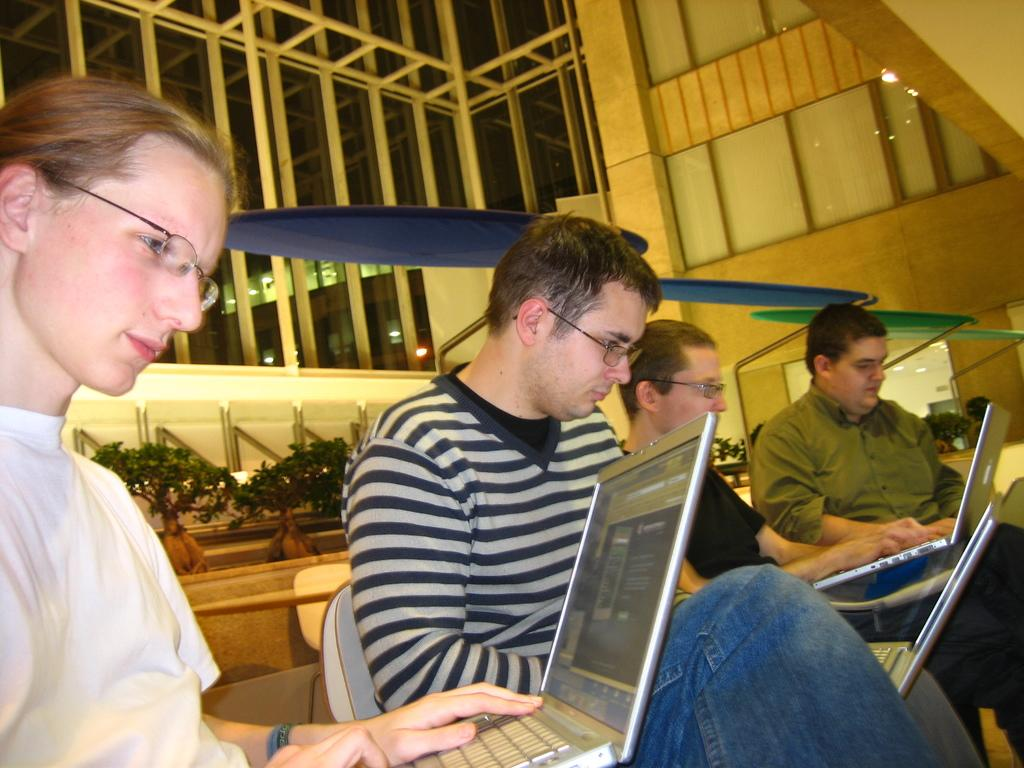How many people are in the image? There are four persons in the image. What are the persons holding in the image? The persons are holding laptops. What can be seen behind the persons? There are chairs visible behind the persons. What is visible in the background of the image? There is a wall and plants in the background of the image. What is visible at the top of the image? There is a wall and glasses visible at the top of the image. How does the beggar in the image measure the distance between the chairs? There is no beggar present in the image, and therefore no such activity can be observed. 